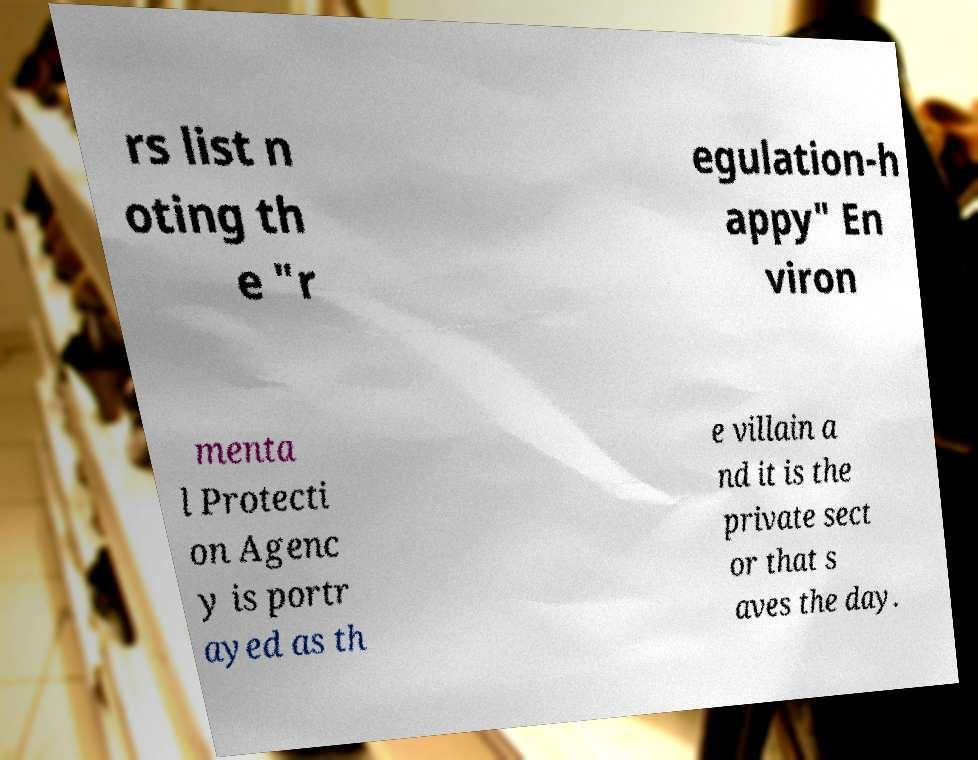For documentation purposes, I need the text within this image transcribed. Could you provide that? rs list n oting th e "r egulation-h appy" En viron menta l Protecti on Agenc y is portr ayed as th e villain a nd it is the private sect or that s aves the day. 